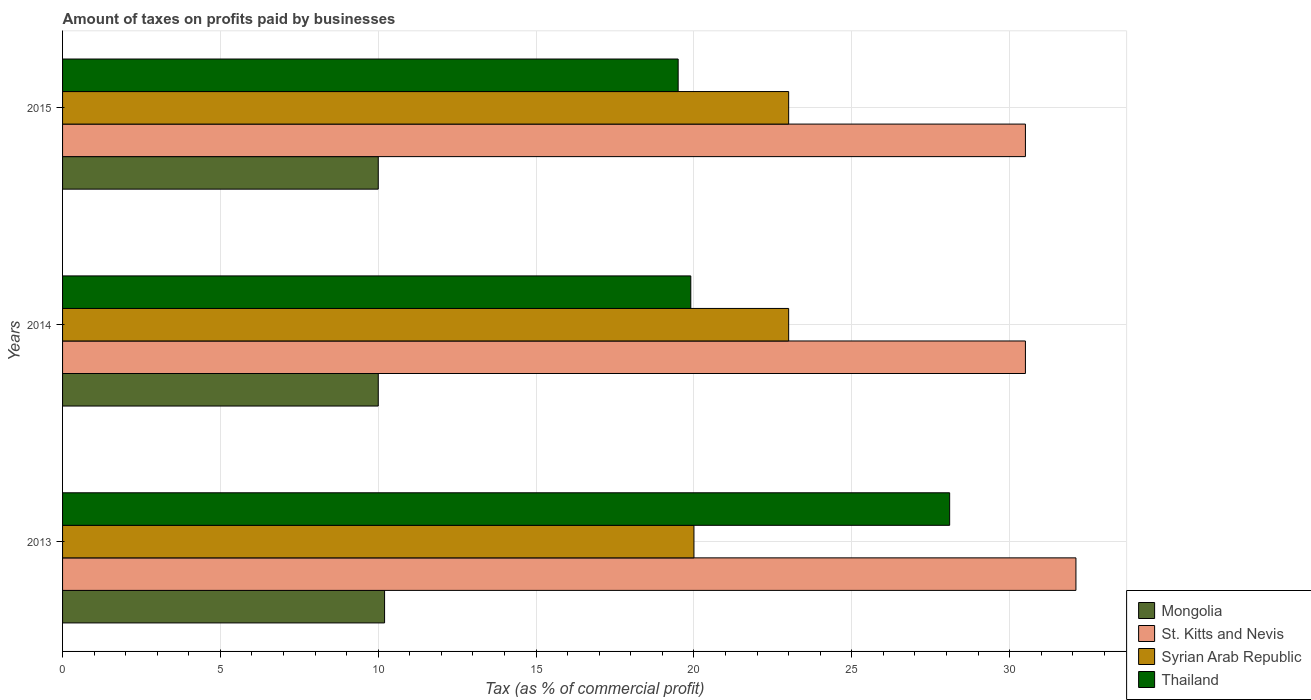How many different coloured bars are there?
Keep it short and to the point. 4. How many groups of bars are there?
Your response must be concise. 3. Are the number of bars on each tick of the Y-axis equal?
Your answer should be compact. Yes. How many bars are there on the 3rd tick from the bottom?
Make the answer very short. 4. What is the label of the 1st group of bars from the top?
Provide a short and direct response. 2015. In how many cases, is the number of bars for a given year not equal to the number of legend labels?
Offer a terse response. 0. What is the percentage of taxes paid by businesses in Syrian Arab Republic in 2015?
Give a very brief answer. 23. Across all years, what is the maximum percentage of taxes paid by businesses in St. Kitts and Nevis?
Offer a very short reply. 32.1. Across all years, what is the minimum percentage of taxes paid by businesses in Syrian Arab Republic?
Provide a short and direct response. 20. In which year was the percentage of taxes paid by businesses in St. Kitts and Nevis maximum?
Offer a terse response. 2013. In which year was the percentage of taxes paid by businesses in Thailand minimum?
Your answer should be compact. 2015. What is the total percentage of taxes paid by businesses in Mongolia in the graph?
Give a very brief answer. 30.2. What is the difference between the percentage of taxes paid by businesses in St. Kitts and Nevis in 2013 and that in 2015?
Make the answer very short. 1.6. What is the difference between the percentage of taxes paid by businesses in Mongolia in 2014 and the percentage of taxes paid by businesses in Syrian Arab Republic in 2013?
Provide a succinct answer. -10. What is the average percentage of taxes paid by businesses in St. Kitts and Nevis per year?
Offer a terse response. 31.03. In the year 2013, what is the difference between the percentage of taxes paid by businesses in Thailand and percentage of taxes paid by businesses in St. Kitts and Nevis?
Make the answer very short. -4. In how many years, is the percentage of taxes paid by businesses in Mongolia greater than 7 %?
Offer a very short reply. 3. What is the ratio of the percentage of taxes paid by businesses in Mongolia in 2013 to that in 2014?
Your answer should be compact. 1.02. Is the percentage of taxes paid by businesses in Thailand in 2014 less than that in 2015?
Provide a short and direct response. No. Is the difference between the percentage of taxes paid by businesses in Thailand in 2013 and 2014 greater than the difference between the percentage of taxes paid by businesses in St. Kitts and Nevis in 2013 and 2014?
Keep it short and to the point. Yes. What is the difference between the highest and the second highest percentage of taxes paid by businesses in Thailand?
Keep it short and to the point. 8.2. What is the difference between the highest and the lowest percentage of taxes paid by businesses in Mongolia?
Give a very brief answer. 0.2. Is the sum of the percentage of taxes paid by businesses in Syrian Arab Republic in 2013 and 2014 greater than the maximum percentage of taxes paid by businesses in Thailand across all years?
Ensure brevity in your answer.  Yes. Is it the case that in every year, the sum of the percentage of taxes paid by businesses in Syrian Arab Republic and percentage of taxes paid by businesses in Mongolia is greater than the sum of percentage of taxes paid by businesses in St. Kitts and Nevis and percentage of taxes paid by businesses in Thailand?
Provide a succinct answer. No. What does the 3rd bar from the top in 2013 represents?
Your answer should be very brief. St. Kitts and Nevis. What does the 1st bar from the bottom in 2013 represents?
Offer a terse response. Mongolia. How many bars are there?
Offer a very short reply. 12. Are all the bars in the graph horizontal?
Make the answer very short. Yes. What is the difference between two consecutive major ticks on the X-axis?
Give a very brief answer. 5. Does the graph contain grids?
Keep it short and to the point. Yes. Where does the legend appear in the graph?
Provide a succinct answer. Bottom right. How many legend labels are there?
Your response must be concise. 4. What is the title of the graph?
Your answer should be compact. Amount of taxes on profits paid by businesses. Does "South Sudan" appear as one of the legend labels in the graph?
Provide a short and direct response. No. What is the label or title of the X-axis?
Provide a short and direct response. Tax (as % of commercial profit). What is the label or title of the Y-axis?
Make the answer very short. Years. What is the Tax (as % of commercial profit) in St. Kitts and Nevis in 2013?
Offer a terse response. 32.1. What is the Tax (as % of commercial profit) in Syrian Arab Republic in 2013?
Keep it short and to the point. 20. What is the Tax (as % of commercial profit) of Thailand in 2013?
Your answer should be compact. 28.1. What is the Tax (as % of commercial profit) of St. Kitts and Nevis in 2014?
Give a very brief answer. 30.5. What is the Tax (as % of commercial profit) of Thailand in 2014?
Offer a terse response. 19.9. What is the Tax (as % of commercial profit) of Mongolia in 2015?
Offer a very short reply. 10. What is the Tax (as % of commercial profit) in St. Kitts and Nevis in 2015?
Your answer should be compact. 30.5. What is the Tax (as % of commercial profit) of Thailand in 2015?
Offer a terse response. 19.5. Across all years, what is the maximum Tax (as % of commercial profit) in St. Kitts and Nevis?
Keep it short and to the point. 32.1. Across all years, what is the maximum Tax (as % of commercial profit) in Thailand?
Your response must be concise. 28.1. Across all years, what is the minimum Tax (as % of commercial profit) of Mongolia?
Offer a very short reply. 10. Across all years, what is the minimum Tax (as % of commercial profit) of St. Kitts and Nevis?
Your answer should be very brief. 30.5. Across all years, what is the minimum Tax (as % of commercial profit) in Syrian Arab Republic?
Give a very brief answer. 20. What is the total Tax (as % of commercial profit) of Mongolia in the graph?
Your answer should be very brief. 30.2. What is the total Tax (as % of commercial profit) of St. Kitts and Nevis in the graph?
Your response must be concise. 93.1. What is the total Tax (as % of commercial profit) in Syrian Arab Republic in the graph?
Ensure brevity in your answer.  66. What is the total Tax (as % of commercial profit) in Thailand in the graph?
Provide a short and direct response. 67.5. What is the difference between the Tax (as % of commercial profit) in Thailand in 2013 and that in 2014?
Make the answer very short. 8.2. What is the difference between the Tax (as % of commercial profit) of Mongolia in 2013 and that in 2015?
Give a very brief answer. 0.2. What is the difference between the Tax (as % of commercial profit) in Syrian Arab Republic in 2013 and that in 2015?
Your response must be concise. -3. What is the difference between the Tax (as % of commercial profit) of Thailand in 2013 and that in 2015?
Give a very brief answer. 8.6. What is the difference between the Tax (as % of commercial profit) in Mongolia in 2014 and that in 2015?
Provide a short and direct response. 0. What is the difference between the Tax (as % of commercial profit) in St. Kitts and Nevis in 2014 and that in 2015?
Your response must be concise. 0. What is the difference between the Tax (as % of commercial profit) of Syrian Arab Republic in 2014 and that in 2015?
Ensure brevity in your answer.  0. What is the difference between the Tax (as % of commercial profit) of Mongolia in 2013 and the Tax (as % of commercial profit) of St. Kitts and Nevis in 2014?
Provide a short and direct response. -20.3. What is the difference between the Tax (as % of commercial profit) in St. Kitts and Nevis in 2013 and the Tax (as % of commercial profit) in Syrian Arab Republic in 2014?
Your answer should be compact. 9.1. What is the difference between the Tax (as % of commercial profit) of Mongolia in 2013 and the Tax (as % of commercial profit) of St. Kitts and Nevis in 2015?
Keep it short and to the point. -20.3. What is the difference between the Tax (as % of commercial profit) of Mongolia in 2013 and the Tax (as % of commercial profit) of Thailand in 2015?
Give a very brief answer. -9.3. What is the difference between the Tax (as % of commercial profit) in St. Kitts and Nevis in 2013 and the Tax (as % of commercial profit) in Thailand in 2015?
Provide a succinct answer. 12.6. What is the difference between the Tax (as % of commercial profit) in Mongolia in 2014 and the Tax (as % of commercial profit) in St. Kitts and Nevis in 2015?
Provide a succinct answer. -20.5. What is the difference between the Tax (as % of commercial profit) of Mongolia in 2014 and the Tax (as % of commercial profit) of Syrian Arab Republic in 2015?
Give a very brief answer. -13. What is the difference between the Tax (as % of commercial profit) in Mongolia in 2014 and the Tax (as % of commercial profit) in Thailand in 2015?
Your answer should be very brief. -9.5. What is the difference between the Tax (as % of commercial profit) of Syrian Arab Republic in 2014 and the Tax (as % of commercial profit) of Thailand in 2015?
Offer a terse response. 3.5. What is the average Tax (as % of commercial profit) of Mongolia per year?
Provide a succinct answer. 10.07. What is the average Tax (as % of commercial profit) in St. Kitts and Nevis per year?
Keep it short and to the point. 31.03. What is the average Tax (as % of commercial profit) in Thailand per year?
Your response must be concise. 22.5. In the year 2013, what is the difference between the Tax (as % of commercial profit) of Mongolia and Tax (as % of commercial profit) of St. Kitts and Nevis?
Make the answer very short. -21.9. In the year 2013, what is the difference between the Tax (as % of commercial profit) of Mongolia and Tax (as % of commercial profit) of Syrian Arab Republic?
Provide a succinct answer. -9.8. In the year 2013, what is the difference between the Tax (as % of commercial profit) of Mongolia and Tax (as % of commercial profit) of Thailand?
Ensure brevity in your answer.  -17.9. In the year 2013, what is the difference between the Tax (as % of commercial profit) in St. Kitts and Nevis and Tax (as % of commercial profit) in Syrian Arab Republic?
Ensure brevity in your answer.  12.1. In the year 2013, what is the difference between the Tax (as % of commercial profit) of St. Kitts and Nevis and Tax (as % of commercial profit) of Thailand?
Keep it short and to the point. 4. In the year 2013, what is the difference between the Tax (as % of commercial profit) of Syrian Arab Republic and Tax (as % of commercial profit) of Thailand?
Give a very brief answer. -8.1. In the year 2014, what is the difference between the Tax (as % of commercial profit) of Mongolia and Tax (as % of commercial profit) of St. Kitts and Nevis?
Provide a short and direct response. -20.5. In the year 2014, what is the difference between the Tax (as % of commercial profit) in Syrian Arab Republic and Tax (as % of commercial profit) in Thailand?
Your response must be concise. 3.1. In the year 2015, what is the difference between the Tax (as % of commercial profit) of Mongolia and Tax (as % of commercial profit) of St. Kitts and Nevis?
Keep it short and to the point. -20.5. In the year 2015, what is the difference between the Tax (as % of commercial profit) of Mongolia and Tax (as % of commercial profit) of Syrian Arab Republic?
Make the answer very short. -13. In the year 2015, what is the difference between the Tax (as % of commercial profit) of Mongolia and Tax (as % of commercial profit) of Thailand?
Your answer should be compact. -9.5. In the year 2015, what is the difference between the Tax (as % of commercial profit) in St. Kitts and Nevis and Tax (as % of commercial profit) in Thailand?
Your response must be concise. 11. In the year 2015, what is the difference between the Tax (as % of commercial profit) of Syrian Arab Republic and Tax (as % of commercial profit) of Thailand?
Your answer should be very brief. 3.5. What is the ratio of the Tax (as % of commercial profit) in Mongolia in 2013 to that in 2014?
Make the answer very short. 1.02. What is the ratio of the Tax (as % of commercial profit) of St. Kitts and Nevis in 2013 to that in 2014?
Your answer should be compact. 1.05. What is the ratio of the Tax (as % of commercial profit) of Syrian Arab Republic in 2013 to that in 2014?
Provide a short and direct response. 0.87. What is the ratio of the Tax (as % of commercial profit) of Thailand in 2013 to that in 2014?
Offer a very short reply. 1.41. What is the ratio of the Tax (as % of commercial profit) in Mongolia in 2013 to that in 2015?
Ensure brevity in your answer.  1.02. What is the ratio of the Tax (as % of commercial profit) in St. Kitts and Nevis in 2013 to that in 2015?
Make the answer very short. 1.05. What is the ratio of the Tax (as % of commercial profit) of Syrian Arab Republic in 2013 to that in 2015?
Give a very brief answer. 0.87. What is the ratio of the Tax (as % of commercial profit) in Thailand in 2013 to that in 2015?
Offer a terse response. 1.44. What is the ratio of the Tax (as % of commercial profit) in Thailand in 2014 to that in 2015?
Ensure brevity in your answer.  1.02. What is the difference between the highest and the second highest Tax (as % of commercial profit) in Mongolia?
Give a very brief answer. 0.2. What is the difference between the highest and the second highest Tax (as % of commercial profit) in St. Kitts and Nevis?
Your response must be concise. 1.6. What is the difference between the highest and the second highest Tax (as % of commercial profit) of Syrian Arab Republic?
Your answer should be compact. 0. What is the difference between the highest and the second highest Tax (as % of commercial profit) of Thailand?
Make the answer very short. 8.2. What is the difference between the highest and the lowest Tax (as % of commercial profit) in Mongolia?
Provide a succinct answer. 0.2. What is the difference between the highest and the lowest Tax (as % of commercial profit) of Thailand?
Offer a very short reply. 8.6. 